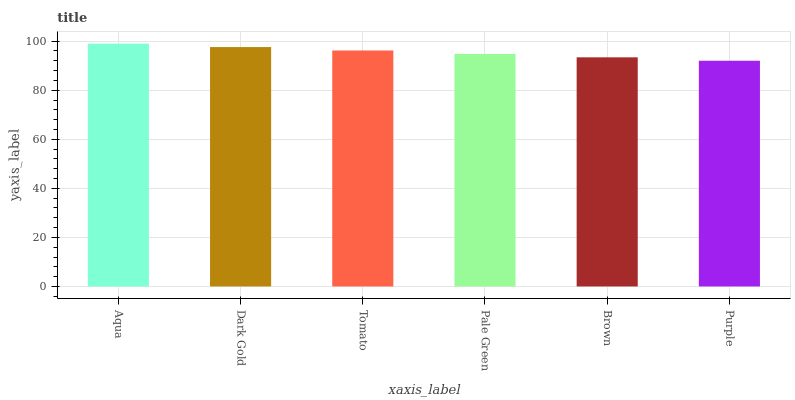Is Purple the minimum?
Answer yes or no. Yes. Is Aqua the maximum?
Answer yes or no. Yes. Is Dark Gold the minimum?
Answer yes or no. No. Is Dark Gold the maximum?
Answer yes or no. No. Is Aqua greater than Dark Gold?
Answer yes or no. Yes. Is Dark Gold less than Aqua?
Answer yes or no. Yes. Is Dark Gold greater than Aqua?
Answer yes or no. No. Is Aqua less than Dark Gold?
Answer yes or no. No. Is Tomato the high median?
Answer yes or no. Yes. Is Pale Green the low median?
Answer yes or no. Yes. Is Purple the high median?
Answer yes or no. No. Is Purple the low median?
Answer yes or no. No. 